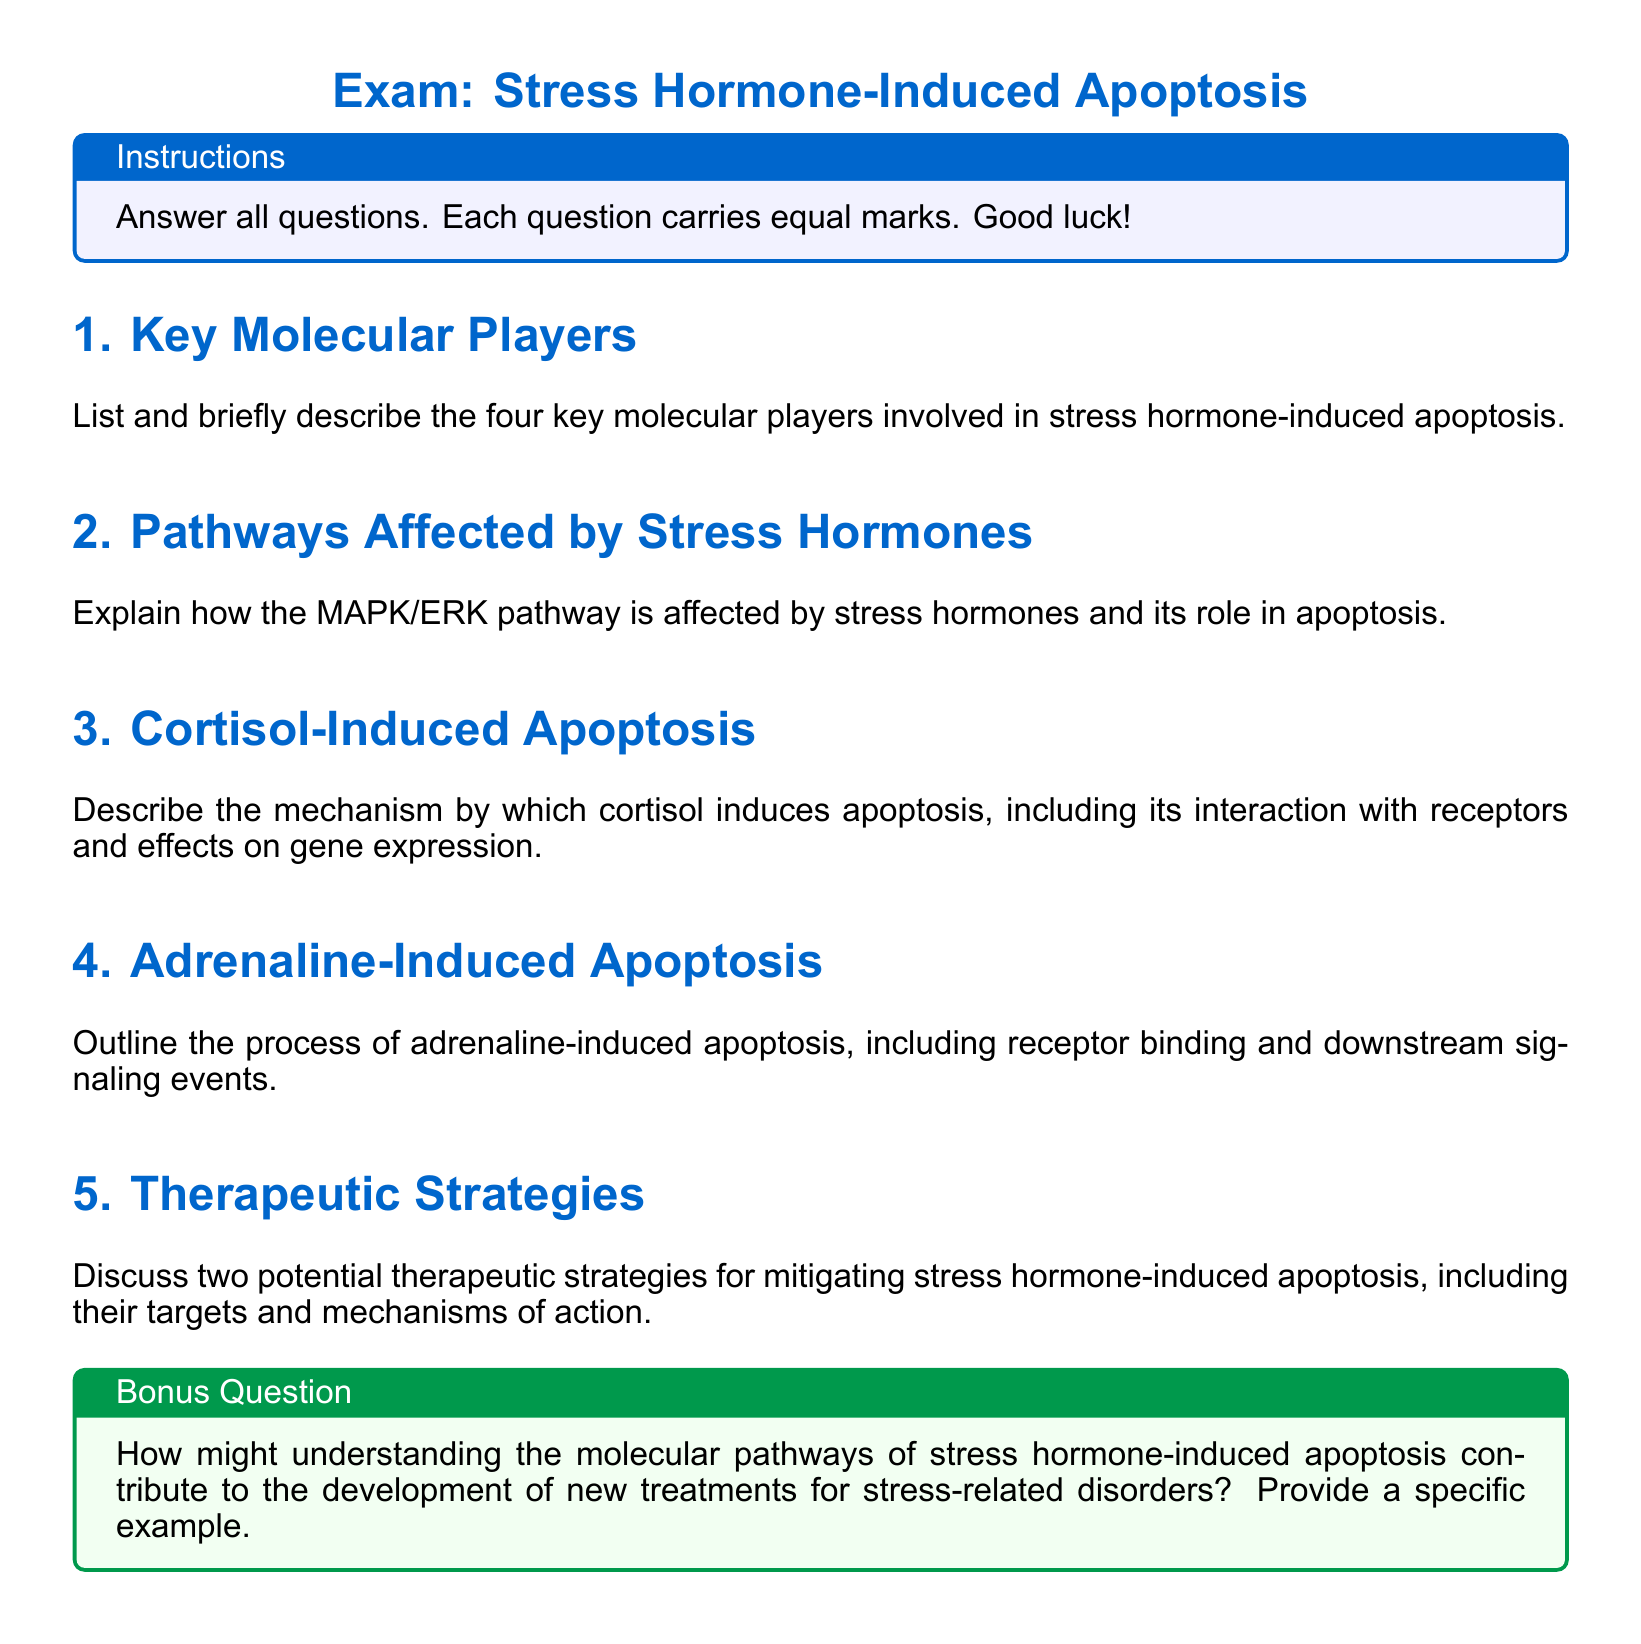What are the key molecular players in stress hormone-induced apoptosis? The question is asking for the specific entities that play a role in the apoptosis process induced by stress hormones as listed in the document.
Answer: four key molecular players How does the MAPK/ERK pathway relate to stress hormones? This question seeks a direct explanation about the relationship between stress hormones and the MAPK/ERK pathway as described in the document.
Answer: affected by stress hormones What hormone is involved in the mechanism described for apoptosis induction? The question is aimed at identifying a specific hormone mentioned in the context of apoptosis mechanisms in the document.
Answer: cortisol What kind of apoptosis is elicited by adrenaline? This question focuses on identifying the type of apoptosis associated with the hormone adrenaline as presented in the document.
Answer: adrenaline-induced apoptosis Name one potential therapeutic strategy for mitigating apoptosis. The question asks for a single therapeutic strategy highlighted in the document, focusing on stress hormone-induced apoptosis.
Answer: therapeutic strategies What is the format of the exam? This question seeks to clarify the structure or format of the assessment outlined in the document.
Answer: short-answer questions What is the significance of understanding molecular pathways in developing treatments? The question probes the implications of the knowledge gained from studying molecular pathways for therapeutic purposes as discussed in the document.
Answer: contribute to the development of new treatments How many questions are there in total in the exam? This question is aimed at finding the total count of questions presented in the exam format of the document.
Answer: five questions 